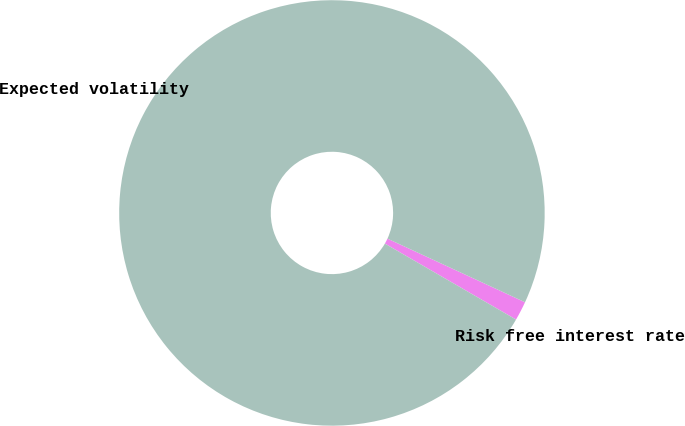<chart> <loc_0><loc_0><loc_500><loc_500><pie_chart><fcel>Risk free interest rate<fcel>Expected volatility<nl><fcel>1.46%<fcel>98.54%<nl></chart> 